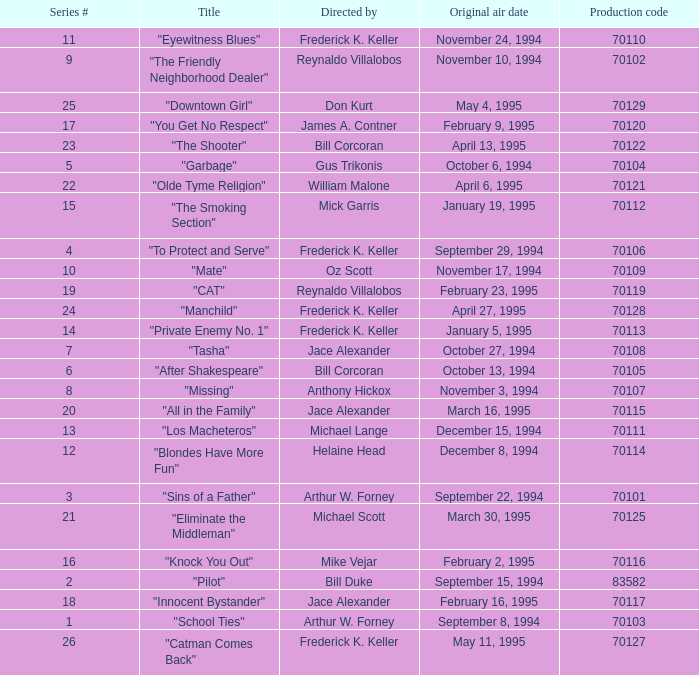For the "Downtown Girl" episode, what was the original air date? May 4, 1995. 